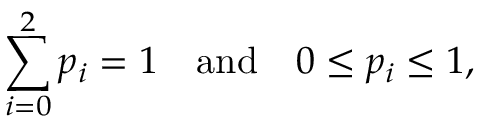<formula> <loc_0><loc_0><loc_500><loc_500>\sum _ { i = 0 } ^ { 2 } p _ { i } = 1 \quad a n d \quad 0 \leq p _ { i } \leq 1 ,</formula> 